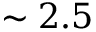<formula> <loc_0><loc_0><loc_500><loc_500>\sim 2 . 5</formula> 